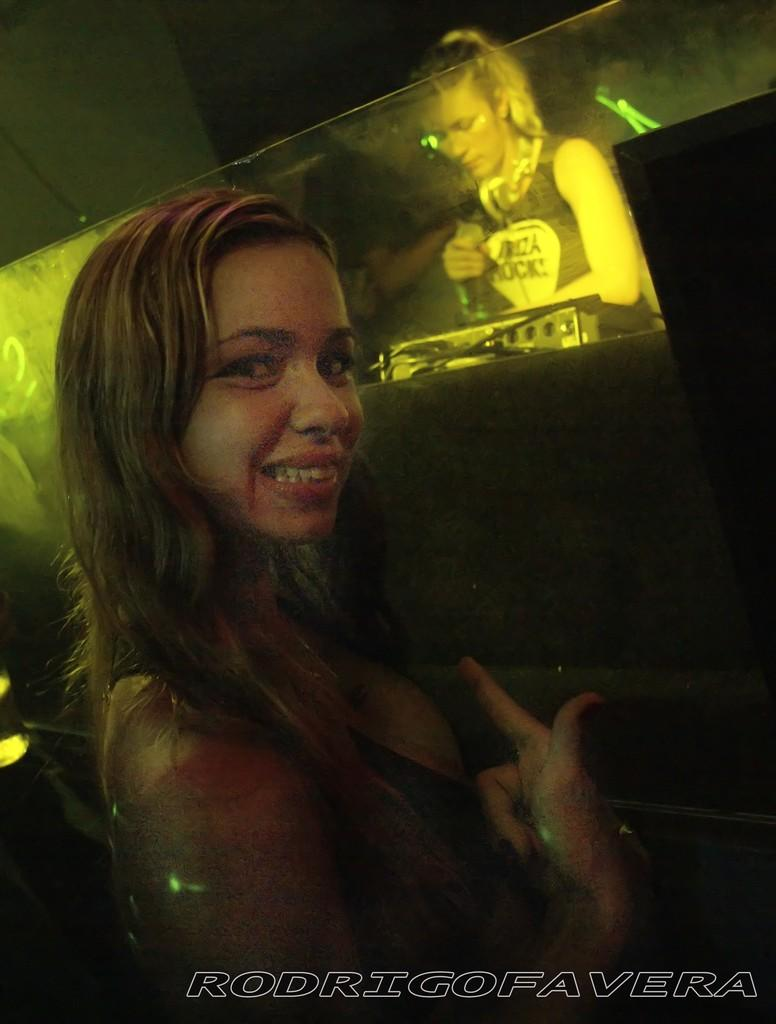What is the primary subject of the image? There is a woman standing in the image. What is the woman doing in the image? The woman is turning her head and smiling. Can you describe the setting of the image? There is another woman standing behind a glass wall in the image. What is the history of the alley behind the glass wall in the image? There is no alley present in the image, and therefore no history to discuss. 